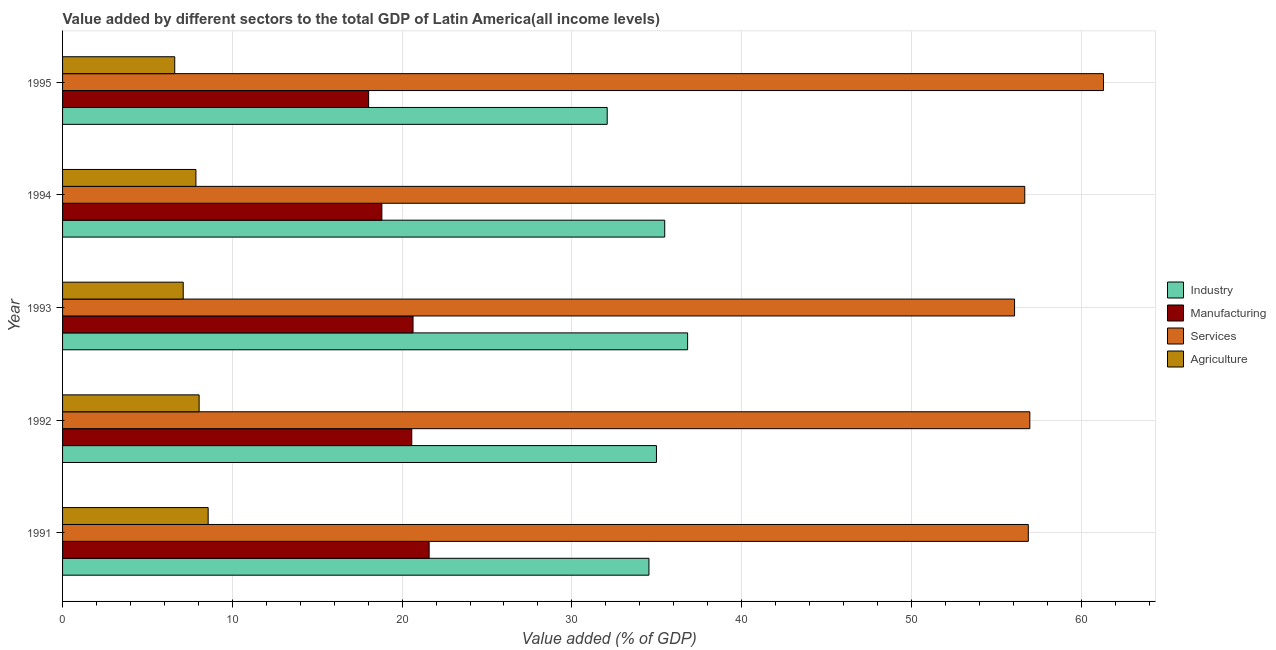How many different coloured bars are there?
Ensure brevity in your answer.  4. How many groups of bars are there?
Make the answer very short. 5. Are the number of bars per tick equal to the number of legend labels?
Give a very brief answer. Yes. Are the number of bars on each tick of the Y-axis equal?
Ensure brevity in your answer.  Yes. How many bars are there on the 3rd tick from the bottom?
Ensure brevity in your answer.  4. In how many cases, is the number of bars for a given year not equal to the number of legend labels?
Keep it short and to the point. 0. What is the value added by agricultural sector in 1991?
Make the answer very short. 8.58. Across all years, what is the maximum value added by services sector?
Offer a terse response. 61.31. Across all years, what is the minimum value added by agricultural sector?
Offer a terse response. 6.61. In which year was the value added by agricultural sector maximum?
Keep it short and to the point. 1991. What is the total value added by services sector in the graph?
Your answer should be compact. 287.92. What is the difference between the value added by industrial sector in 1991 and that in 1995?
Your answer should be compact. 2.46. What is the difference between the value added by agricultural sector in 1994 and the value added by manufacturing sector in 1993?
Your response must be concise. -12.79. What is the average value added by industrial sector per year?
Provide a succinct answer. 34.78. In the year 1992, what is the difference between the value added by agricultural sector and value added by services sector?
Give a very brief answer. -48.93. What is the ratio of the value added by manufacturing sector in 1993 to that in 1995?
Give a very brief answer. 1.15. Is the value added by industrial sector in 1991 less than that in 1992?
Keep it short and to the point. Yes. What is the difference between the highest and the second highest value added by industrial sector?
Keep it short and to the point. 1.35. What is the difference between the highest and the lowest value added by industrial sector?
Offer a very short reply. 4.74. What does the 4th bar from the top in 1991 represents?
Offer a terse response. Industry. What does the 4th bar from the bottom in 1991 represents?
Provide a short and direct response. Agriculture. Is it the case that in every year, the sum of the value added by industrial sector and value added by manufacturing sector is greater than the value added by services sector?
Your answer should be very brief. No. Are all the bars in the graph horizontal?
Make the answer very short. Yes. Are the values on the major ticks of X-axis written in scientific E-notation?
Your answer should be very brief. No. Does the graph contain any zero values?
Your answer should be compact. No. Where does the legend appear in the graph?
Your answer should be very brief. Center right. How are the legend labels stacked?
Your answer should be very brief. Vertical. What is the title of the graph?
Your answer should be compact. Value added by different sectors to the total GDP of Latin America(all income levels). Does "Burnt food" appear as one of the legend labels in the graph?
Keep it short and to the point. No. What is the label or title of the X-axis?
Make the answer very short. Value added (% of GDP). What is the Value added (% of GDP) of Industry in 1991?
Offer a very short reply. 34.54. What is the Value added (% of GDP) in Manufacturing in 1991?
Offer a very short reply. 21.59. What is the Value added (% of GDP) of Services in 1991?
Offer a terse response. 56.88. What is the Value added (% of GDP) of Agriculture in 1991?
Your answer should be compact. 8.58. What is the Value added (% of GDP) in Industry in 1992?
Your answer should be very brief. 34.98. What is the Value added (% of GDP) of Manufacturing in 1992?
Keep it short and to the point. 20.57. What is the Value added (% of GDP) of Services in 1992?
Your answer should be very brief. 56.97. What is the Value added (% of GDP) in Agriculture in 1992?
Ensure brevity in your answer.  8.04. What is the Value added (% of GDP) in Industry in 1993?
Make the answer very short. 36.82. What is the Value added (% of GDP) in Manufacturing in 1993?
Provide a succinct answer. 20.64. What is the Value added (% of GDP) of Services in 1993?
Your answer should be very brief. 56.08. What is the Value added (% of GDP) in Agriculture in 1993?
Provide a short and direct response. 7.11. What is the Value added (% of GDP) of Industry in 1994?
Keep it short and to the point. 35.47. What is the Value added (% of GDP) in Manufacturing in 1994?
Your answer should be compact. 18.81. What is the Value added (% of GDP) of Services in 1994?
Make the answer very short. 56.68. What is the Value added (% of GDP) in Agriculture in 1994?
Your response must be concise. 7.85. What is the Value added (% of GDP) of Industry in 1995?
Provide a short and direct response. 32.08. What is the Value added (% of GDP) in Manufacturing in 1995?
Give a very brief answer. 18.03. What is the Value added (% of GDP) of Services in 1995?
Your answer should be very brief. 61.31. What is the Value added (% of GDP) in Agriculture in 1995?
Make the answer very short. 6.61. Across all years, what is the maximum Value added (% of GDP) in Industry?
Offer a terse response. 36.82. Across all years, what is the maximum Value added (% of GDP) in Manufacturing?
Provide a succinct answer. 21.59. Across all years, what is the maximum Value added (% of GDP) in Services?
Offer a very short reply. 61.31. Across all years, what is the maximum Value added (% of GDP) in Agriculture?
Offer a terse response. 8.58. Across all years, what is the minimum Value added (% of GDP) in Industry?
Offer a very short reply. 32.08. Across all years, what is the minimum Value added (% of GDP) of Manufacturing?
Offer a very short reply. 18.03. Across all years, what is the minimum Value added (% of GDP) in Services?
Offer a very short reply. 56.08. Across all years, what is the minimum Value added (% of GDP) in Agriculture?
Offer a very short reply. 6.61. What is the total Value added (% of GDP) in Industry in the graph?
Offer a very short reply. 173.89. What is the total Value added (% of GDP) of Manufacturing in the graph?
Give a very brief answer. 99.64. What is the total Value added (% of GDP) in Services in the graph?
Provide a short and direct response. 287.92. What is the total Value added (% of GDP) in Agriculture in the graph?
Ensure brevity in your answer.  38.19. What is the difference between the Value added (% of GDP) in Industry in 1991 and that in 1992?
Your response must be concise. -0.44. What is the difference between the Value added (% of GDP) in Manufacturing in 1991 and that in 1992?
Your answer should be compact. 1.02. What is the difference between the Value added (% of GDP) of Services in 1991 and that in 1992?
Offer a terse response. -0.09. What is the difference between the Value added (% of GDP) of Agriculture in 1991 and that in 1992?
Offer a very short reply. 0.53. What is the difference between the Value added (% of GDP) in Industry in 1991 and that in 1993?
Give a very brief answer. -2.28. What is the difference between the Value added (% of GDP) in Manufacturing in 1991 and that in 1993?
Your answer should be very brief. 0.95. What is the difference between the Value added (% of GDP) of Services in 1991 and that in 1993?
Your answer should be very brief. 0.81. What is the difference between the Value added (% of GDP) in Agriculture in 1991 and that in 1993?
Give a very brief answer. 1.47. What is the difference between the Value added (% of GDP) of Industry in 1991 and that in 1994?
Your response must be concise. -0.93. What is the difference between the Value added (% of GDP) of Manufacturing in 1991 and that in 1994?
Ensure brevity in your answer.  2.78. What is the difference between the Value added (% of GDP) of Services in 1991 and that in 1994?
Offer a terse response. 0.21. What is the difference between the Value added (% of GDP) in Agriculture in 1991 and that in 1994?
Provide a succinct answer. 0.72. What is the difference between the Value added (% of GDP) in Industry in 1991 and that in 1995?
Make the answer very short. 2.46. What is the difference between the Value added (% of GDP) of Manufacturing in 1991 and that in 1995?
Offer a terse response. 3.56. What is the difference between the Value added (% of GDP) in Services in 1991 and that in 1995?
Your answer should be compact. -4.43. What is the difference between the Value added (% of GDP) of Agriculture in 1991 and that in 1995?
Keep it short and to the point. 1.97. What is the difference between the Value added (% of GDP) in Industry in 1992 and that in 1993?
Give a very brief answer. -1.84. What is the difference between the Value added (% of GDP) in Manufacturing in 1992 and that in 1993?
Give a very brief answer. -0.08. What is the difference between the Value added (% of GDP) in Services in 1992 and that in 1993?
Your response must be concise. 0.9. What is the difference between the Value added (% of GDP) in Agriculture in 1992 and that in 1993?
Make the answer very short. 0.94. What is the difference between the Value added (% of GDP) in Industry in 1992 and that in 1994?
Give a very brief answer. -0.49. What is the difference between the Value added (% of GDP) of Manufacturing in 1992 and that in 1994?
Your answer should be very brief. 1.76. What is the difference between the Value added (% of GDP) of Services in 1992 and that in 1994?
Offer a very short reply. 0.3. What is the difference between the Value added (% of GDP) of Agriculture in 1992 and that in 1994?
Your answer should be very brief. 0.19. What is the difference between the Value added (% of GDP) in Industry in 1992 and that in 1995?
Provide a succinct answer. 2.9. What is the difference between the Value added (% of GDP) in Manufacturing in 1992 and that in 1995?
Your answer should be very brief. 2.54. What is the difference between the Value added (% of GDP) in Services in 1992 and that in 1995?
Give a very brief answer. -4.34. What is the difference between the Value added (% of GDP) in Agriculture in 1992 and that in 1995?
Give a very brief answer. 1.44. What is the difference between the Value added (% of GDP) in Industry in 1993 and that in 1994?
Provide a short and direct response. 1.35. What is the difference between the Value added (% of GDP) in Manufacturing in 1993 and that in 1994?
Offer a terse response. 1.84. What is the difference between the Value added (% of GDP) of Services in 1993 and that in 1994?
Your answer should be compact. -0.6. What is the difference between the Value added (% of GDP) in Agriculture in 1993 and that in 1994?
Your answer should be compact. -0.75. What is the difference between the Value added (% of GDP) of Industry in 1993 and that in 1995?
Provide a succinct answer. 4.74. What is the difference between the Value added (% of GDP) of Manufacturing in 1993 and that in 1995?
Offer a very short reply. 2.62. What is the difference between the Value added (% of GDP) in Services in 1993 and that in 1995?
Ensure brevity in your answer.  -5.24. What is the difference between the Value added (% of GDP) in Agriculture in 1993 and that in 1995?
Provide a succinct answer. 0.5. What is the difference between the Value added (% of GDP) of Industry in 1994 and that in 1995?
Keep it short and to the point. 3.39. What is the difference between the Value added (% of GDP) in Manufacturing in 1994 and that in 1995?
Your answer should be very brief. 0.78. What is the difference between the Value added (% of GDP) in Services in 1994 and that in 1995?
Your answer should be very brief. -4.64. What is the difference between the Value added (% of GDP) in Agriculture in 1994 and that in 1995?
Ensure brevity in your answer.  1.25. What is the difference between the Value added (% of GDP) in Industry in 1991 and the Value added (% of GDP) in Manufacturing in 1992?
Keep it short and to the point. 13.97. What is the difference between the Value added (% of GDP) of Industry in 1991 and the Value added (% of GDP) of Services in 1992?
Offer a terse response. -22.44. What is the difference between the Value added (% of GDP) in Industry in 1991 and the Value added (% of GDP) in Agriculture in 1992?
Keep it short and to the point. 26.5. What is the difference between the Value added (% of GDP) in Manufacturing in 1991 and the Value added (% of GDP) in Services in 1992?
Provide a short and direct response. -35.38. What is the difference between the Value added (% of GDP) in Manufacturing in 1991 and the Value added (% of GDP) in Agriculture in 1992?
Give a very brief answer. 13.55. What is the difference between the Value added (% of GDP) of Services in 1991 and the Value added (% of GDP) of Agriculture in 1992?
Your answer should be very brief. 48.84. What is the difference between the Value added (% of GDP) of Industry in 1991 and the Value added (% of GDP) of Manufacturing in 1993?
Give a very brief answer. 13.9. What is the difference between the Value added (% of GDP) in Industry in 1991 and the Value added (% of GDP) in Services in 1993?
Keep it short and to the point. -21.54. What is the difference between the Value added (% of GDP) of Industry in 1991 and the Value added (% of GDP) of Agriculture in 1993?
Your answer should be compact. 27.43. What is the difference between the Value added (% of GDP) of Manufacturing in 1991 and the Value added (% of GDP) of Services in 1993?
Offer a very short reply. -34.48. What is the difference between the Value added (% of GDP) of Manufacturing in 1991 and the Value added (% of GDP) of Agriculture in 1993?
Give a very brief answer. 14.48. What is the difference between the Value added (% of GDP) of Services in 1991 and the Value added (% of GDP) of Agriculture in 1993?
Your response must be concise. 49.78. What is the difference between the Value added (% of GDP) in Industry in 1991 and the Value added (% of GDP) in Manufacturing in 1994?
Offer a terse response. 15.73. What is the difference between the Value added (% of GDP) in Industry in 1991 and the Value added (% of GDP) in Services in 1994?
Provide a short and direct response. -22.14. What is the difference between the Value added (% of GDP) of Industry in 1991 and the Value added (% of GDP) of Agriculture in 1994?
Make the answer very short. 26.68. What is the difference between the Value added (% of GDP) of Manufacturing in 1991 and the Value added (% of GDP) of Services in 1994?
Keep it short and to the point. -35.08. What is the difference between the Value added (% of GDP) in Manufacturing in 1991 and the Value added (% of GDP) in Agriculture in 1994?
Offer a terse response. 13.74. What is the difference between the Value added (% of GDP) in Services in 1991 and the Value added (% of GDP) in Agriculture in 1994?
Your answer should be compact. 49.03. What is the difference between the Value added (% of GDP) of Industry in 1991 and the Value added (% of GDP) of Manufacturing in 1995?
Make the answer very short. 16.51. What is the difference between the Value added (% of GDP) of Industry in 1991 and the Value added (% of GDP) of Services in 1995?
Provide a succinct answer. -26.77. What is the difference between the Value added (% of GDP) in Industry in 1991 and the Value added (% of GDP) in Agriculture in 1995?
Your answer should be compact. 27.93. What is the difference between the Value added (% of GDP) of Manufacturing in 1991 and the Value added (% of GDP) of Services in 1995?
Offer a terse response. -39.72. What is the difference between the Value added (% of GDP) in Manufacturing in 1991 and the Value added (% of GDP) in Agriculture in 1995?
Provide a short and direct response. 14.98. What is the difference between the Value added (% of GDP) in Services in 1991 and the Value added (% of GDP) in Agriculture in 1995?
Keep it short and to the point. 50.28. What is the difference between the Value added (% of GDP) of Industry in 1992 and the Value added (% of GDP) of Manufacturing in 1993?
Your answer should be compact. 14.34. What is the difference between the Value added (% of GDP) in Industry in 1992 and the Value added (% of GDP) in Services in 1993?
Keep it short and to the point. -21.09. What is the difference between the Value added (% of GDP) in Industry in 1992 and the Value added (% of GDP) in Agriculture in 1993?
Offer a terse response. 27.87. What is the difference between the Value added (% of GDP) in Manufacturing in 1992 and the Value added (% of GDP) in Services in 1993?
Provide a short and direct response. -35.51. What is the difference between the Value added (% of GDP) in Manufacturing in 1992 and the Value added (% of GDP) in Agriculture in 1993?
Provide a succinct answer. 13.46. What is the difference between the Value added (% of GDP) of Services in 1992 and the Value added (% of GDP) of Agriculture in 1993?
Make the answer very short. 49.87. What is the difference between the Value added (% of GDP) in Industry in 1992 and the Value added (% of GDP) in Manufacturing in 1994?
Provide a short and direct response. 16.17. What is the difference between the Value added (% of GDP) of Industry in 1992 and the Value added (% of GDP) of Services in 1994?
Give a very brief answer. -21.7. What is the difference between the Value added (% of GDP) of Industry in 1992 and the Value added (% of GDP) of Agriculture in 1994?
Your response must be concise. 27.13. What is the difference between the Value added (% of GDP) in Manufacturing in 1992 and the Value added (% of GDP) in Services in 1994?
Keep it short and to the point. -36.11. What is the difference between the Value added (% of GDP) of Manufacturing in 1992 and the Value added (% of GDP) of Agriculture in 1994?
Make the answer very short. 12.71. What is the difference between the Value added (% of GDP) in Services in 1992 and the Value added (% of GDP) in Agriculture in 1994?
Provide a short and direct response. 49.12. What is the difference between the Value added (% of GDP) of Industry in 1992 and the Value added (% of GDP) of Manufacturing in 1995?
Your answer should be very brief. 16.95. What is the difference between the Value added (% of GDP) in Industry in 1992 and the Value added (% of GDP) in Services in 1995?
Keep it short and to the point. -26.33. What is the difference between the Value added (% of GDP) in Industry in 1992 and the Value added (% of GDP) in Agriculture in 1995?
Give a very brief answer. 28.37. What is the difference between the Value added (% of GDP) in Manufacturing in 1992 and the Value added (% of GDP) in Services in 1995?
Make the answer very short. -40.74. What is the difference between the Value added (% of GDP) of Manufacturing in 1992 and the Value added (% of GDP) of Agriculture in 1995?
Keep it short and to the point. 13.96. What is the difference between the Value added (% of GDP) of Services in 1992 and the Value added (% of GDP) of Agriculture in 1995?
Your answer should be compact. 50.37. What is the difference between the Value added (% of GDP) of Industry in 1993 and the Value added (% of GDP) of Manufacturing in 1994?
Your answer should be very brief. 18.01. What is the difference between the Value added (% of GDP) of Industry in 1993 and the Value added (% of GDP) of Services in 1994?
Your answer should be very brief. -19.86. What is the difference between the Value added (% of GDP) in Industry in 1993 and the Value added (% of GDP) in Agriculture in 1994?
Your answer should be compact. 28.96. What is the difference between the Value added (% of GDP) of Manufacturing in 1993 and the Value added (% of GDP) of Services in 1994?
Ensure brevity in your answer.  -36.03. What is the difference between the Value added (% of GDP) in Manufacturing in 1993 and the Value added (% of GDP) in Agriculture in 1994?
Your answer should be very brief. 12.79. What is the difference between the Value added (% of GDP) in Services in 1993 and the Value added (% of GDP) in Agriculture in 1994?
Offer a terse response. 48.22. What is the difference between the Value added (% of GDP) of Industry in 1993 and the Value added (% of GDP) of Manufacturing in 1995?
Ensure brevity in your answer.  18.79. What is the difference between the Value added (% of GDP) in Industry in 1993 and the Value added (% of GDP) in Services in 1995?
Make the answer very short. -24.49. What is the difference between the Value added (% of GDP) in Industry in 1993 and the Value added (% of GDP) in Agriculture in 1995?
Make the answer very short. 30.21. What is the difference between the Value added (% of GDP) in Manufacturing in 1993 and the Value added (% of GDP) in Services in 1995?
Make the answer very short. -40.67. What is the difference between the Value added (% of GDP) in Manufacturing in 1993 and the Value added (% of GDP) in Agriculture in 1995?
Keep it short and to the point. 14.04. What is the difference between the Value added (% of GDP) in Services in 1993 and the Value added (% of GDP) in Agriculture in 1995?
Your answer should be very brief. 49.47. What is the difference between the Value added (% of GDP) of Industry in 1994 and the Value added (% of GDP) of Manufacturing in 1995?
Offer a very short reply. 17.44. What is the difference between the Value added (% of GDP) in Industry in 1994 and the Value added (% of GDP) in Services in 1995?
Your response must be concise. -25.84. What is the difference between the Value added (% of GDP) in Industry in 1994 and the Value added (% of GDP) in Agriculture in 1995?
Ensure brevity in your answer.  28.86. What is the difference between the Value added (% of GDP) of Manufacturing in 1994 and the Value added (% of GDP) of Services in 1995?
Keep it short and to the point. -42.5. What is the difference between the Value added (% of GDP) in Manufacturing in 1994 and the Value added (% of GDP) in Agriculture in 1995?
Offer a terse response. 12.2. What is the difference between the Value added (% of GDP) of Services in 1994 and the Value added (% of GDP) of Agriculture in 1995?
Give a very brief answer. 50.07. What is the average Value added (% of GDP) in Industry per year?
Your answer should be very brief. 34.78. What is the average Value added (% of GDP) in Manufacturing per year?
Keep it short and to the point. 19.93. What is the average Value added (% of GDP) of Services per year?
Make the answer very short. 57.58. What is the average Value added (% of GDP) in Agriculture per year?
Offer a terse response. 7.64. In the year 1991, what is the difference between the Value added (% of GDP) of Industry and Value added (% of GDP) of Manufacturing?
Your answer should be compact. 12.95. In the year 1991, what is the difference between the Value added (% of GDP) of Industry and Value added (% of GDP) of Services?
Make the answer very short. -22.35. In the year 1991, what is the difference between the Value added (% of GDP) of Industry and Value added (% of GDP) of Agriculture?
Provide a succinct answer. 25.96. In the year 1991, what is the difference between the Value added (% of GDP) of Manufacturing and Value added (% of GDP) of Services?
Provide a succinct answer. -35.29. In the year 1991, what is the difference between the Value added (% of GDP) of Manufacturing and Value added (% of GDP) of Agriculture?
Keep it short and to the point. 13.02. In the year 1991, what is the difference between the Value added (% of GDP) of Services and Value added (% of GDP) of Agriculture?
Offer a terse response. 48.31. In the year 1992, what is the difference between the Value added (% of GDP) in Industry and Value added (% of GDP) in Manufacturing?
Give a very brief answer. 14.41. In the year 1992, what is the difference between the Value added (% of GDP) in Industry and Value added (% of GDP) in Services?
Make the answer very short. -21.99. In the year 1992, what is the difference between the Value added (% of GDP) in Industry and Value added (% of GDP) in Agriculture?
Keep it short and to the point. 26.94. In the year 1992, what is the difference between the Value added (% of GDP) of Manufacturing and Value added (% of GDP) of Services?
Offer a very short reply. -36.41. In the year 1992, what is the difference between the Value added (% of GDP) of Manufacturing and Value added (% of GDP) of Agriculture?
Ensure brevity in your answer.  12.52. In the year 1992, what is the difference between the Value added (% of GDP) of Services and Value added (% of GDP) of Agriculture?
Offer a terse response. 48.93. In the year 1993, what is the difference between the Value added (% of GDP) of Industry and Value added (% of GDP) of Manufacturing?
Keep it short and to the point. 16.17. In the year 1993, what is the difference between the Value added (% of GDP) of Industry and Value added (% of GDP) of Services?
Your response must be concise. -19.26. In the year 1993, what is the difference between the Value added (% of GDP) in Industry and Value added (% of GDP) in Agriculture?
Provide a short and direct response. 29.71. In the year 1993, what is the difference between the Value added (% of GDP) in Manufacturing and Value added (% of GDP) in Services?
Keep it short and to the point. -35.43. In the year 1993, what is the difference between the Value added (% of GDP) in Manufacturing and Value added (% of GDP) in Agriculture?
Ensure brevity in your answer.  13.54. In the year 1993, what is the difference between the Value added (% of GDP) in Services and Value added (% of GDP) in Agriculture?
Your response must be concise. 48.97. In the year 1994, what is the difference between the Value added (% of GDP) of Industry and Value added (% of GDP) of Manufacturing?
Offer a very short reply. 16.66. In the year 1994, what is the difference between the Value added (% of GDP) of Industry and Value added (% of GDP) of Services?
Offer a terse response. -21.21. In the year 1994, what is the difference between the Value added (% of GDP) in Industry and Value added (% of GDP) in Agriculture?
Offer a very short reply. 27.61. In the year 1994, what is the difference between the Value added (% of GDP) in Manufacturing and Value added (% of GDP) in Services?
Your answer should be compact. -37.87. In the year 1994, what is the difference between the Value added (% of GDP) of Manufacturing and Value added (% of GDP) of Agriculture?
Keep it short and to the point. 10.95. In the year 1994, what is the difference between the Value added (% of GDP) of Services and Value added (% of GDP) of Agriculture?
Give a very brief answer. 48.82. In the year 1995, what is the difference between the Value added (% of GDP) in Industry and Value added (% of GDP) in Manufacturing?
Keep it short and to the point. 14.05. In the year 1995, what is the difference between the Value added (% of GDP) of Industry and Value added (% of GDP) of Services?
Offer a very short reply. -29.23. In the year 1995, what is the difference between the Value added (% of GDP) in Industry and Value added (% of GDP) in Agriculture?
Your response must be concise. 25.47. In the year 1995, what is the difference between the Value added (% of GDP) in Manufacturing and Value added (% of GDP) in Services?
Your answer should be compact. -43.28. In the year 1995, what is the difference between the Value added (% of GDP) in Manufacturing and Value added (% of GDP) in Agriculture?
Your answer should be compact. 11.42. In the year 1995, what is the difference between the Value added (% of GDP) of Services and Value added (% of GDP) of Agriculture?
Ensure brevity in your answer.  54.7. What is the ratio of the Value added (% of GDP) of Industry in 1991 to that in 1992?
Make the answer very short. 0.99. What is the ratio of the Value added (% of GDP) in Manufacturing in 1991 to that in 1992?
Ensure brevity in your answer.  1.05. What is the ratio of the Value added (% of GDP) in Agriculture in 1991 to that in 1992?
Offer a very short reply. 1.07. What is the ratio of the Value added (% of GDP) of Industry in 1991 to that in 1993?
Your answer should be very brief. 0.94. What is the ratio of the Value added (% of GDP) in Manufacturing in 1991 to that in 1993?
Keep it short and to the point. 1.05. What is the ratio of the Value added (% of GDP) of Services in 1991 to that in 1993?
Offer a very short reply. 1.01. What is the ratio of the Value added (% of GDP) of Agriculture in 1991 to that in 1993?
Ensure brevity in your answer.  1.21. What is the ratio of the Value added (% of GDP) in Industry in 1991 to that in 1994?
Offer a very short reply. 0.97. What is the ratio of the Value added (% of GDP) in Manufacturing in 1991 to that in 1994?
Your answer should be very brief. 1.15. What is the ratio of the Value added (% of GDP) in Services in 1991 to that in 1994?
Your response must be concise. 1. What is the ratio of the Value added (% of GDP) of Agriculture in 1991 to that in 1994?
Keep it short and to the point. 1.09. What is the ratio of the Value added (% of GDP) in Industry in 1991 to that in 1995?
Your response must be concise. 1.08. What is the ratio of the Value added (% of GDP) of Manufacturing in 1991 to that in 1995?
Your response must be concise. 1.2. What is the ratio of the Value added (% of GDP) of Services in 1991 to that in 1995?
Your answer should be compact. 0.93. What is the ratio of the Value added (% of GDP) of Agriculture in 1991 to that in 1995?
Your answer should be compact. 1.3. What is the ratio of the Value added (% of GDP) in Industry in 1992 to that in 1993?
Offer a terse response. 0.95. What is the ratio of the Value added (% of GDP) in Manufacturing in 1992 to that in 1993?
Offer a very short reply. 1. What is the ratio of the Value added (% of GDP) in Services in 1992 to that in 1993?
Give a very brief answer. 1.02. What is the ratio of the Value added (% of GDP) in Agriculture in 1992 to that in 1993?
Offer a terse response. 1.13. What is the ratio of the Value added (% of GDP) of Industry in 1992 to that in 1994?
Provide a succinct answer. 0.99. What is the ratio of the Value added (% of GDP) in Manufacturing in 1992 to that in 1994?
Provide a succinct answer. 1.09. What is the ratio of the Value added (% of GDP) in Agriculture in 1992 to that in 1994?
Keep it short and to the point. 1.02. What is the ratio of the Value added (% of GDP) of Industry in 1992 to that in 1995?
Keep it short and to the point. 1.09. What is the ratio of the Value added (% of GDP) of Manufacturing in 1992 to that in 1995?
Ensure brevity in your answer.  1.14. What is the ratio of the Value added (% of GDP) in Services in 1992 to that in 1995?
Offer a very short reply. 0.93. What is the ratio of the Value added (% of GDP) of Agriculture in 1992 to that in 1995?
Provide a succinct answer. 1.22. What is the ratio of the Value added (% of GDP) of Industry in 1993 to that in 1994?
Ensure brevity in your answer.  1.04. What is the ratio of the Value added (% of GDP) in Manufacturing in 1993 to that in 1994?
Ensure brevity in your answer.  1.1. What is the ratio of the Value added (% of GDP) of Services in 1993 to that in 1994?
Your answer should be compact. 0.99. What is the ratio of the Value added (% of GDP) in Agriculture in 1993 to that in 1994?
Your response must be concise. 0.9. What is the ratio of the Value added (% of GDP) of Industry in 1993 to that in 1995?
Give a very brief answer. 1.15. What is the ratio of the Value added (% of GDP) in Manufacturing in 1993 to that in 1995?
Give a very brief answer. 1.15. What is the ratio of the Value added (% of GDP) of Services in 1993 to that in 1995?
Your response must be concise. 0.91. What is the ratio of the Value added (% of GDP) of Agriculture in 1993 to that in 1995?
Provide a short and direct response. 1.08. What is the ratio of the Value added (% of GDP) in Industry in 1994 to that in 1995?
Provide a short and direct response. 1.11. What is the ratio of the Value added (% of GDP) of Manufacturing in 1994 to that in 1995?
Your response must be concise. 1.04. What is the ratio of the Value added (% of GDP) in Services in 1994 to that in 1995?
Offer a terse response. 0.92. What is the ratio of the Value added (% of GDP) in Agriculture in 1994 to that in 1995?
Provide a short and direct response. 1.19. What is the difference between the highest and the second highest Value added (% of GDP) of Industry?
Give a very brief answer. 1.35. What is the difference between the highest and the second highest Value added (% of GDP) in Manufacturing?
Your response must be concise. 0.95. What is the difference between the highest and the second highest Value added (% of GDP) in Services?
Offer a terse response. 4.34. What is the difference between the highest and the second highest Value added (% of GDP) of Agriculture?
Offer a terse response. 0.53. What is the difference between the highest and the lowest Value added (% of GDP) in Industry?
Offer a very short reply. 4.74. What is the difference between the highest and the lowest Value added (% of GDP) in Manufacturing?
Offer a terse response. 3.56. What is the difference between the highest and the lowest Value added (% of GDP) of Services?
Offer a terse response. 5.24. What is the difference between the highest and the lowest Value added (% of GDP) of Agriculture?
Offer a terse response. 1.97. 